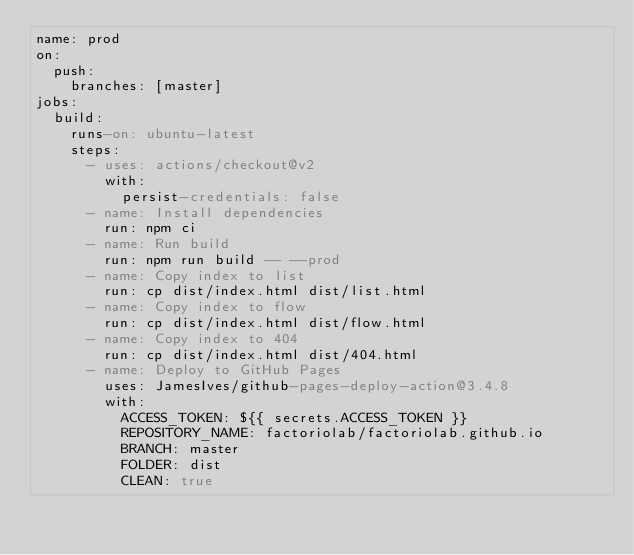Convert code to text. <code><loc_0><loc_0><loc_500><loc_500><_YAML_>name: prod
on:
  push:
    branches: [master]
jobs:
  build:
    runs-on: ubuntu-latest
    steps:
      - uses: actions/checkout@v2
        with:
          persist-credentials: false
      - name: Install dependencies
        run: npm ci
      - name: Run build
        run: npm run build -- --prod
      - name: Copy index to list
        run: cp dist/index.html dist/list.html
      - name: Copy index to flow
        run: cp dist/index.html dist/flow.html
      - name: Copy index to 404
        run: cp dist/index.html dist/404.html
      - name: Deploy to GitHub Pages
        uses: JamesIves/github-pages-deploy-action@3.4.8
        with:
          ACCESS_TOKEN: ${{ secrets.ACCESS_TOKEN }}
          REPOSITORY_NAME: factoriolab/factoriolab.github.io
          BRANCH: master
          FOLDER: dist
          CLEAN: true
</code> 